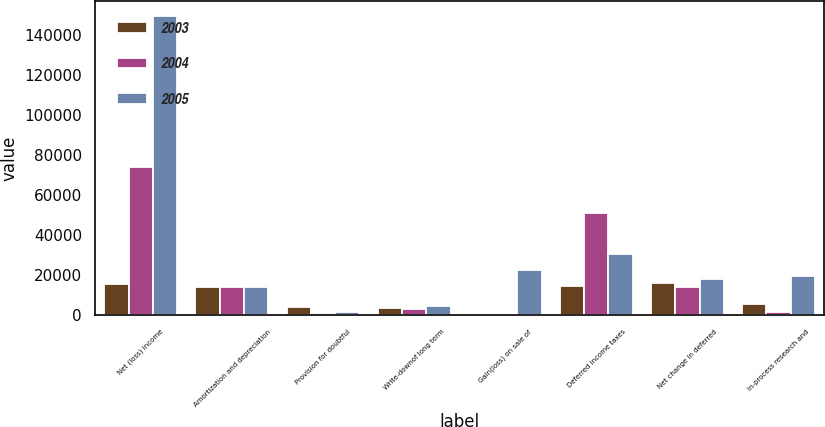Convert chart. <chart><loc_0><loc_0><loc_500><loc_500><stacked_bar_chart><ecel><fcel>Net (loss) income<fcel>Amortization and depreciation<fcel>Provision for doubtful<fcel>Write-downof long term<fcel>Gain(loss) on sale of<fcel>Deferred income taxes<fcel>Net change in deferred<fcel>In-process research and<nl><fcel>2003<fcel>15478<fcel>14019<fcel>4094<fcel>3582<fcel>502<fcel>14647<fcel>15982<fcel>5700<nl><fcel>2004<fcel>74337<fcel>14019<fcel>927<fcel>2983<fcel>833<fcel>50855<fcel>14019<fcel>1638<nl><fcel>2005<fcel>149724<fcel>14019<fcel>1577<fcel>4525<fcel>22366<fcel>30503<fcel>18107<fcel>19850<nl></chart> 